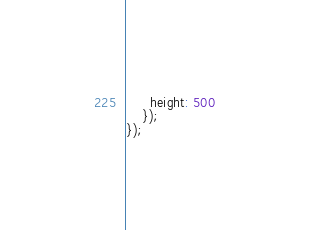Convert code to text. <code><loc_0><loc_0><loc_500><loc_500><_JavaScript_>	  height: 500
	});
});</code> 